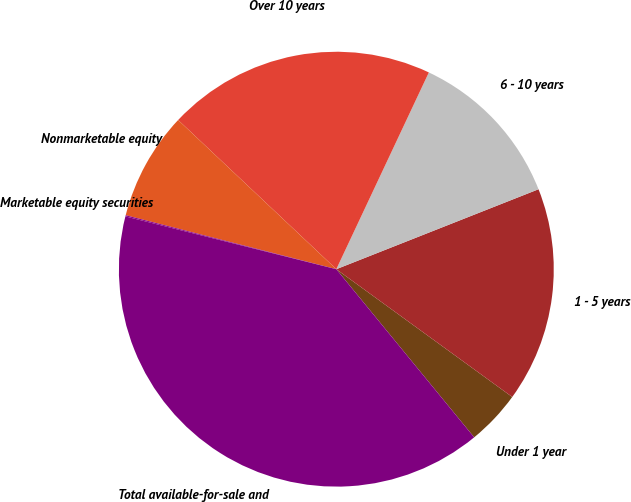Convert chart. <chart><loc_0><loc_0><loc_500><loc_500><pie_chart><fcel>Under 1 year<fcel>1 - 5 years<fcel>6 - 10 years<fcel>Over 10 years<fcel>Nonmarketable equity<fcel>Marketable equity securities<fcel>Total available-for-sale and<nl><fcel>4.07%<fcel>15.99%<fcel>12.01%<fcel>19.96%<fcel>8.04%<fcel>0.09%<fcel>39.83%<nl></chart> 